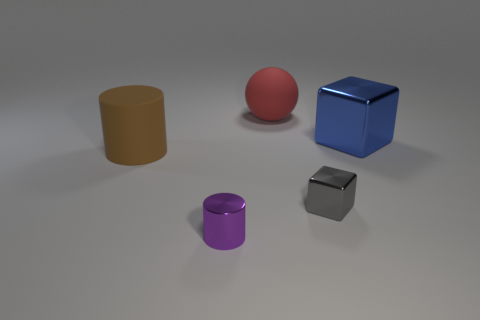What number of gray objects are there? Upon reviewing the image, I can confirm that there are two gray objects. 